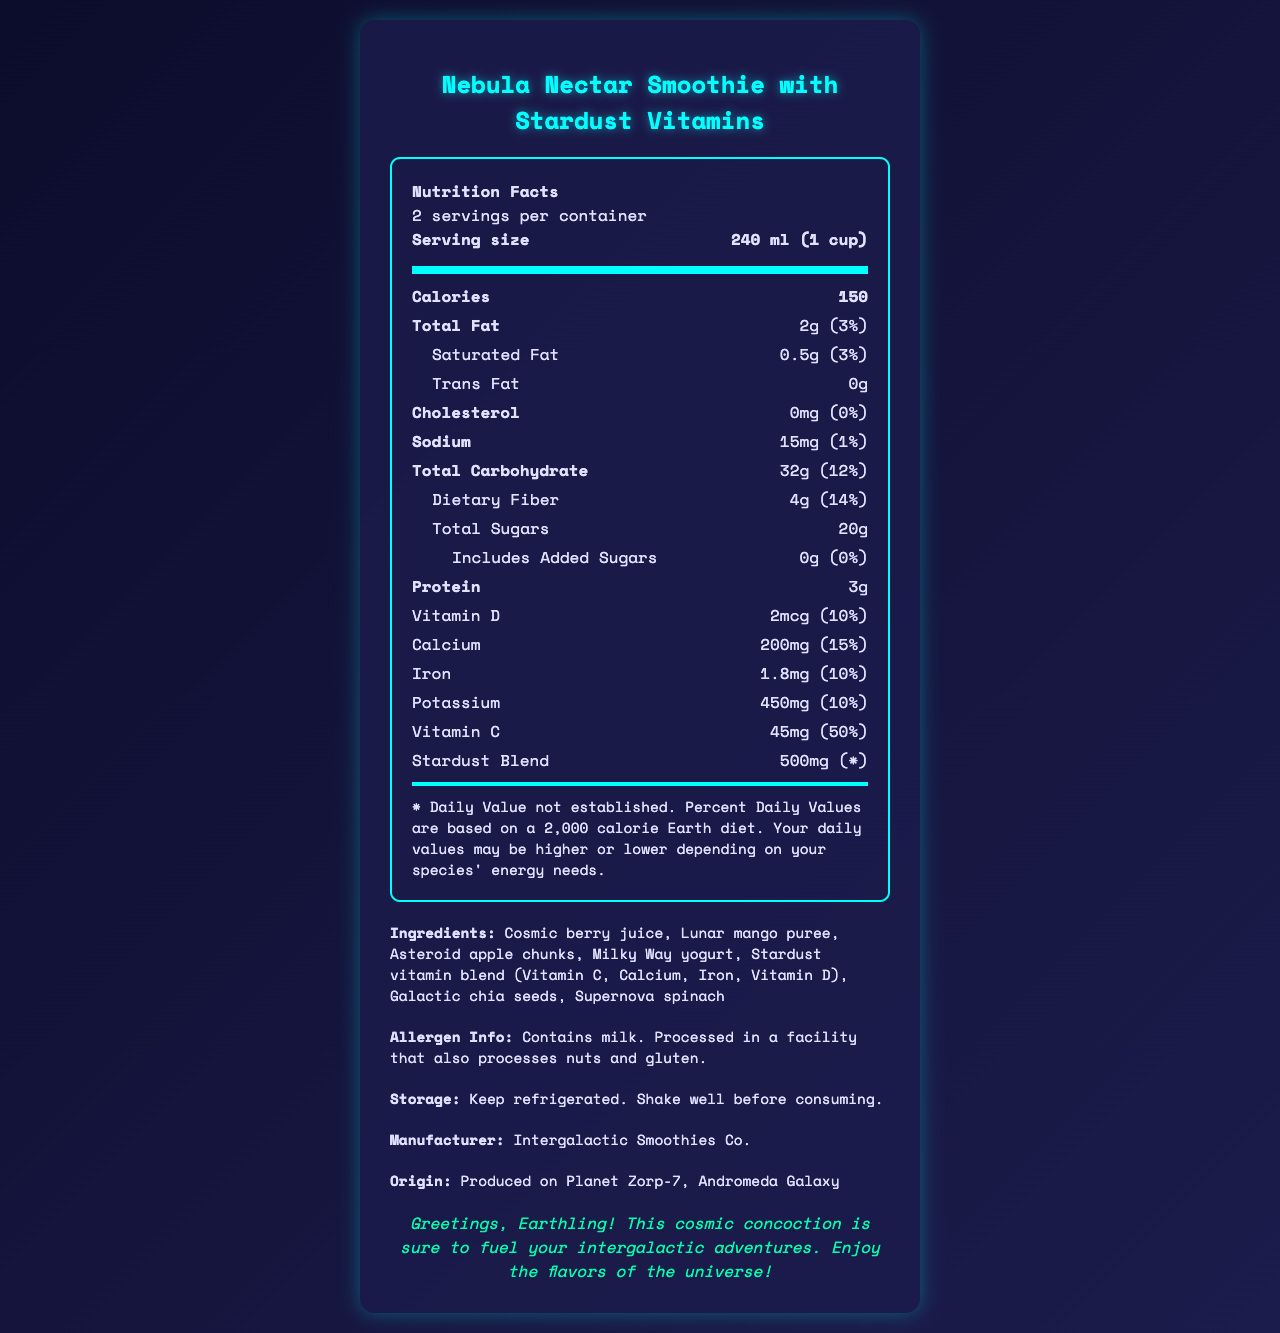what is the serving size of the Nebula Nectar Smoothie? The serving size is mentioned in the document as "240 ml (1 cup)".
Answer: 240 ml (1 cup) how many servings are there per container? The document states, "2 servings per container".
Answer: 2 servings how many grams of total fat are there per serving? The document shows the total fat per serving as "2g".
Answer: 2g What is the daily value percentage for total carbohydrates? The daily value percentage for total carbohydrates is listed as "12%".
Answer: 12% How much dietary fiber does one serving contain? The dietary fiber per serving is indicated as "4g".
Answer: 4g how many grams of saturated fat are there per serving? The document lists "0.5g" as the amount of saturated fat per serving.
Answer: 0.5g What is the amount of calcium in one serving? The amount of calcium in one serving is mentioned as "200mg".
Answer: 200mg How many milligrams of vitamin C does each serving contain? A. 10mg B. 20mg C. 45mg D. 60mg The document specifies that each serving contains "45mg" of vitamin C.
Answer: C. 45mg What percentage of daily value is provided by the protein content in the smoothie? A. 1% B. 2% C. 3% D. 4% While the document lists the protein content as "3g," it does not provide a specific daily value percentage for it based on the standard 2,000 calorie diet.
Answer: B. 2% Does the product contain any trans fat? The document indicates that the trans fat content is "0g", hence there is no trans fat in the product.
Answer: No Is the manufacturer's origin mentioned in the document? The document states that it is produced on "Planet Zorp-7, Andromeda Galaxy".
Answer: Yes Does the Nebula Nectar Smoothie have any added sugars? The document indicates that there are "0g" of added sugars.
Answer: No Summarize the key nutritional facts of the Nebula Nectar Smoothie. The document provides detailed nutritional information including calories, fats, sodium, carbohydrates, fibers, sugars, protein, and various vitamins and minerals for each serving of the Nebula Nectar Smoothie.
Answer: The Nebula Nectar Smoothie has 150 calories per serving, 2g of total fat, 0.5g of saturated fat, 0g trans fat, 15mg of sodium, 32g of total carbohydrates, 4g of dietary fiber, 20g of total sugars, 3g of protein, and includes notable amounts of vitamin D, calcium, iron, potassium, vitamin C, and a unique stardust blend. Who can provide more information about the energy needs specific to your species? The document mentions that daily values may vary based on species' energy needs, but it does not provide any specific contact or source for further information.
Answer: Cannot be determined 